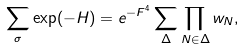Convert formula to latex. <formula><loc_0><loc_0><loc_500><loc_500>\sum _ { \sigma } \exp ( - H ) = e ^ { - F ^ { 4 } } \sum _ { \Delta } \prod _ { N \in \Delta } w _ { N } ,</formula> 